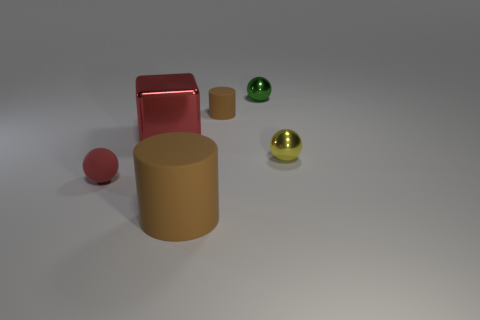There is a object that is both in front of the small yellow shiny thing and behind the large brown cylinder; what is its shape?
Offer a terse response. Sphere. Does the large cylinder have the same material as the ball behind the big cube?
Provide a short and direct response. No. There is a red rubber thing; are there any cylinders in front of it?
Give a very brief answer. Yes. What number of objects are either shiny spheres or brown objects that are to the right of the large rubber cylinder?
Your answer should be compact. 3. What is the color of the tiny rubber thing behind the ball left of the big red thing?
Give a very brief answer. Brown. What number of other things are the same material as the red sphere?
Keep it short and to the point. 2. What number of metallic things are either large brown cylinders or big gray things?
Offer a very short reply. 0. The other metallic thing that is the same shape as the small green metallic thing is what color?
Your response must be concise. Yellow. What number of things are tiny yellow shiny balls or small cylinders?
Your answer should be very brief. 2. There is a yellow object that is made of the same material as the small green thing; what shape is it?
Your response must be concise. Sphere. 